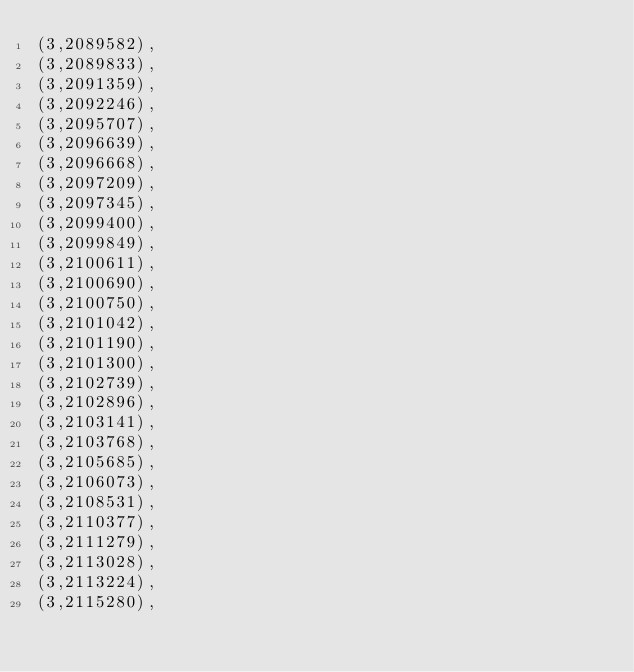<code> <loc_0><loc_0><loc_500><loc_500><_SQL_>(3,2089582),
(3,2089833),
(3,2091359),
(3,2092246),
(3,2095707),
(3,2096639),
(3,2096668),
(3,2097209),
(3,2097345),
(3,2099400),
(3,2099849),
(3,2100611),
(3,2100690),
(3,2100750),
(3,2101042),
(3,2101190),
(3,2101300),
(3,2102739),
(3,2102896),
(3,2103141),
(3,2103768),
(3,2105685),
(3,2106073),
(3,2108531),
(3,2110377),
(3,2111279),
(3,2113028),
(3,2113224),
(3,2115280),</code> 